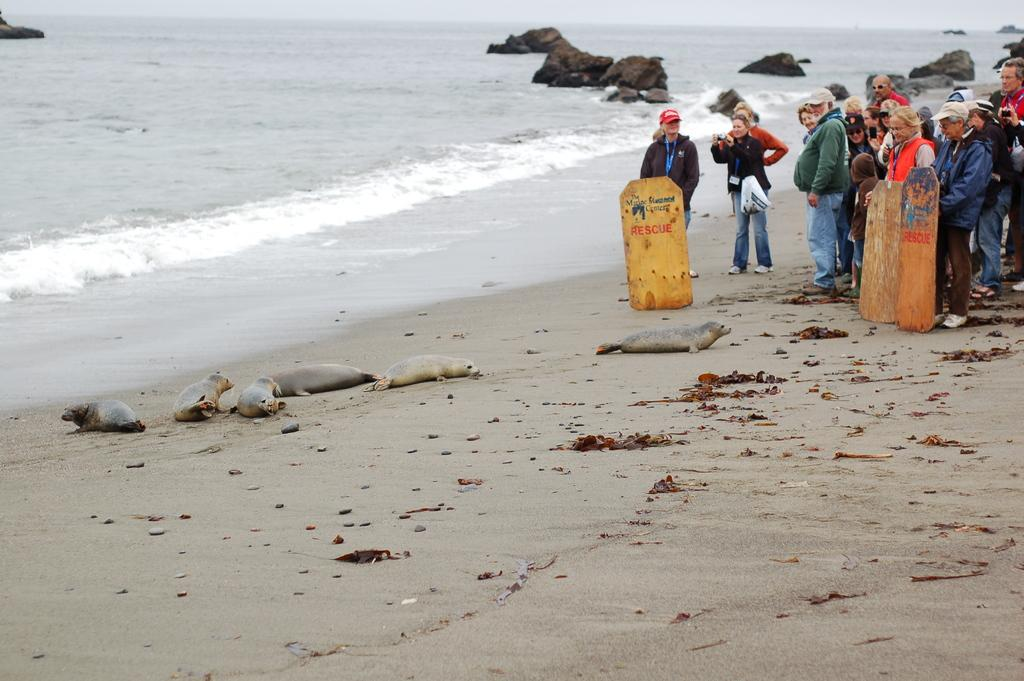What type of animals are on the sand in the image? There are Harbor seals on the sand in the image. Where are the people located in the image? The people are standing in the right corner of the image. What can be seen in the background of the image? There is water visible in the background of the image. What is the rate at which the chess game is being played in the image? There is no chess game present in the image, so it is not possible to determine the rate at which a game might be played. 